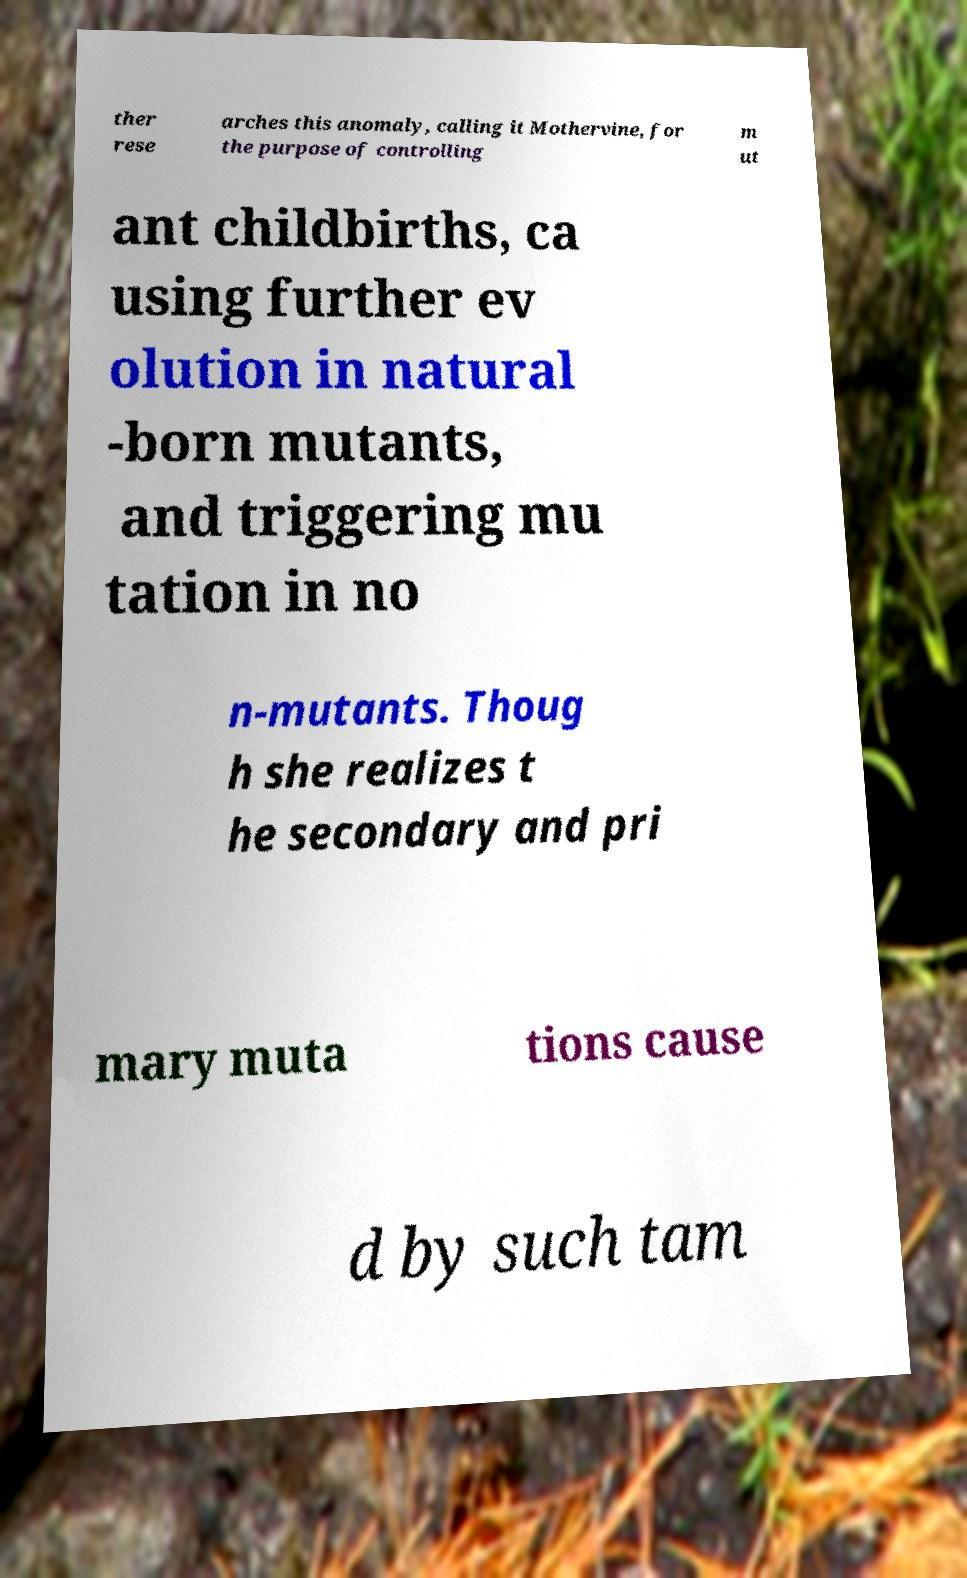For documentation purposes, I need the text within this image transcribed. Could you provide that? ther rese arches this anomaly, calling it Mothervine, for the purpose of controlling m ut ant childbirths, ca using further ev olution in natural -born mutants, and triggering mu tation in no n-mutants. Thoug h she realizes t he secondary and pri mary muta tions cause d by such tam 